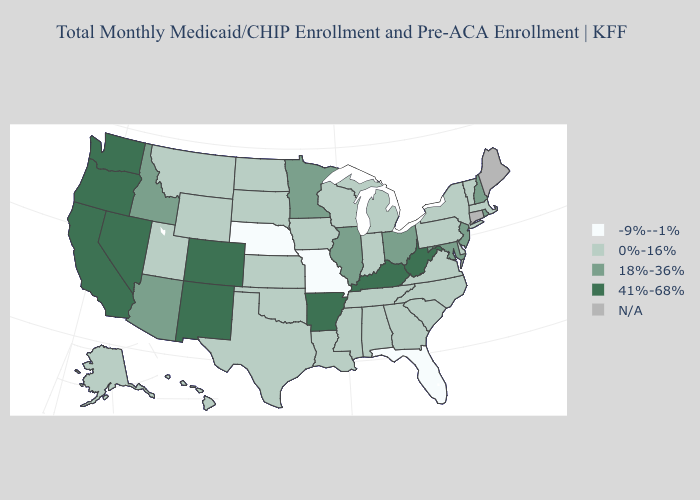Does the first symbol in the legend represent the smallest category?
Short answer required. Yes. Name the states that have a value in the range -9%--1%?
Short answer required. Florida, Missouri, Nebraska. Among the states that border Colorado , does Wyoming have the lowest value?
Be succinct. No. Which states have the highest value in the USA?
Quick response, please. Arkansas, California, Colorado, Kentucky, Nevada, New Mexico, Oregon, Washington, West Virginia. How many symbols are there in the legend?
Short answer required. 5. Name the states that have a value in the range 0%-16%?
Keep it brief. Alabama, Alaska, Delaware, Georgia, Hawaii, Indiana, Iowa, Kansas, Louisiana, Massachusetts, Michigan, Mississippi, Montana, New York, North Carolina, North Dakota, Oklahoma, Pennsylvania, South Carolina, South Dakota, Tennessee, Texas, Utah, Vermont, Virginia, Wisconsin, Wyoming. What is the lowest value in the MidWest?
Keep it brief. -9%--1%. Does Missouri have the lowest value in the USA?
Be succinct. Yes. Does the first symbol in the legend represent the smallest category?
Be succinct. Yes. What is the value of Oregon?
Give a very brief answer. 41%-68%. What is the value of Mississippi?
Concise answer only. 0%-16%. Is the legend a continuous bar?
Keep it brief. No. What is the value of California?
Be succinct. 41%-68%. Does Alaska have the lowest value in the USA?
Answer briefly. No. Which states have the highest value in the USA?
Write a very short answer. Arkansas, California, Colorado, Kentucky, Nevada, New Mexico, Oregon, Washington, West Virginia. 